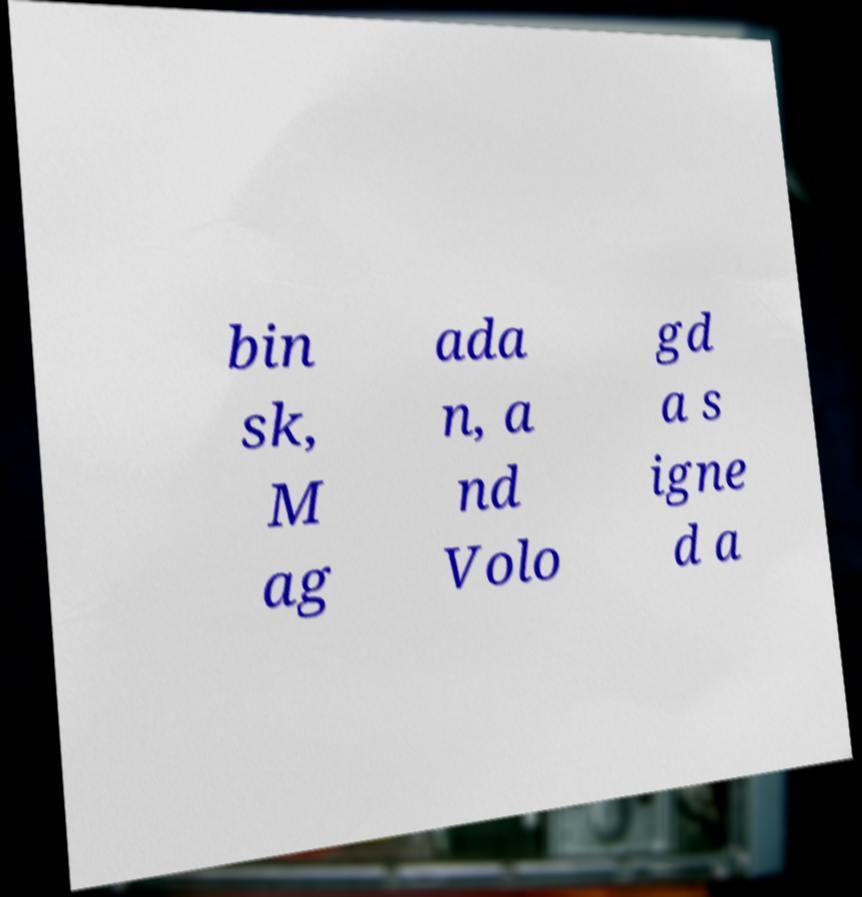There's text embedded in this image that I need extracted. Can you transcribe it verbatim? bin sk, M ag ada n, a nd Volo gd a s igne d a 